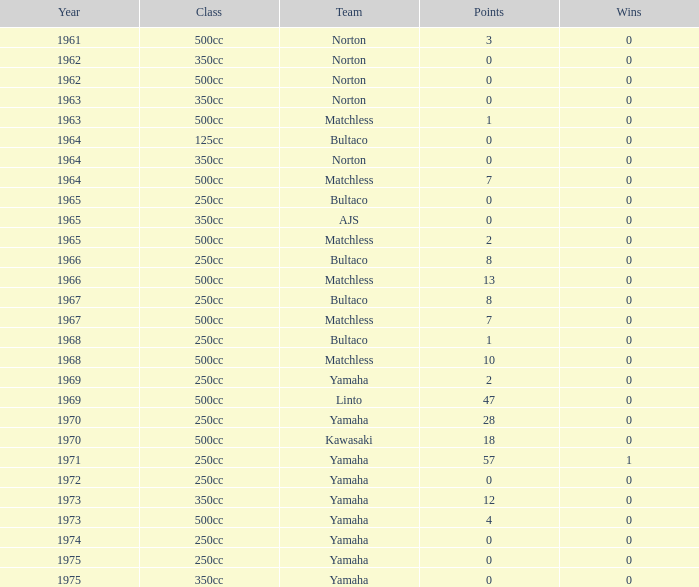What is the mean number of victories for bultaco in the 250cc category after 1966, with 8 points? 0.0. 